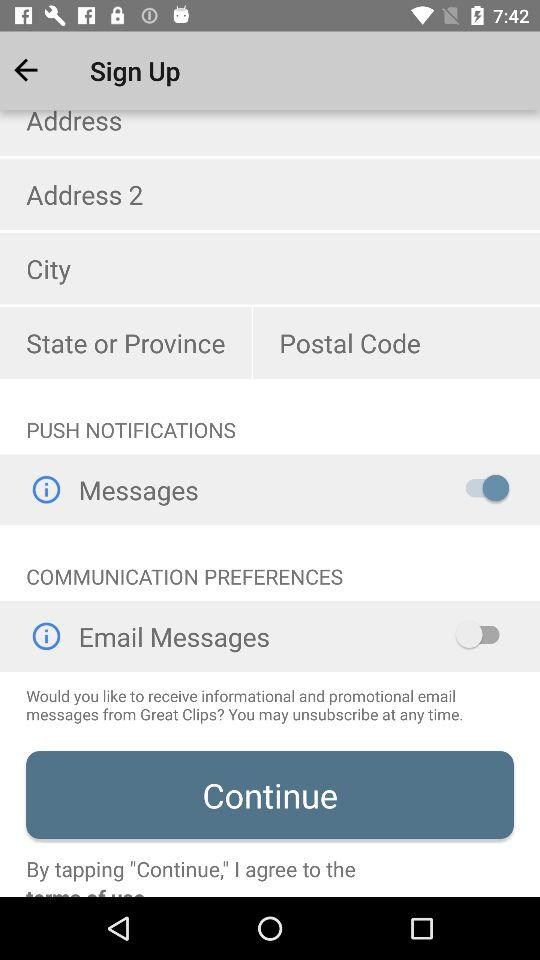What is the status of "Messages" in "PUSH NOTIFICATIONS"? The status is "on". 